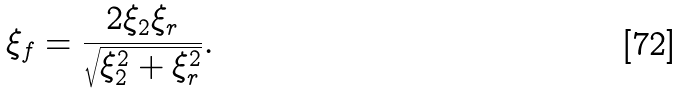Convert formula to latex. <formula><loc_0><loc_0><loc_500><loc_500>\xi _ { f } = \frac { 2 \xi _ { 2 } \xi _ { r } } { \sqrt { \xi _ { 2 } ^ { 2 } + \xi _ { r } ^ { 2 } } } .</formula> 